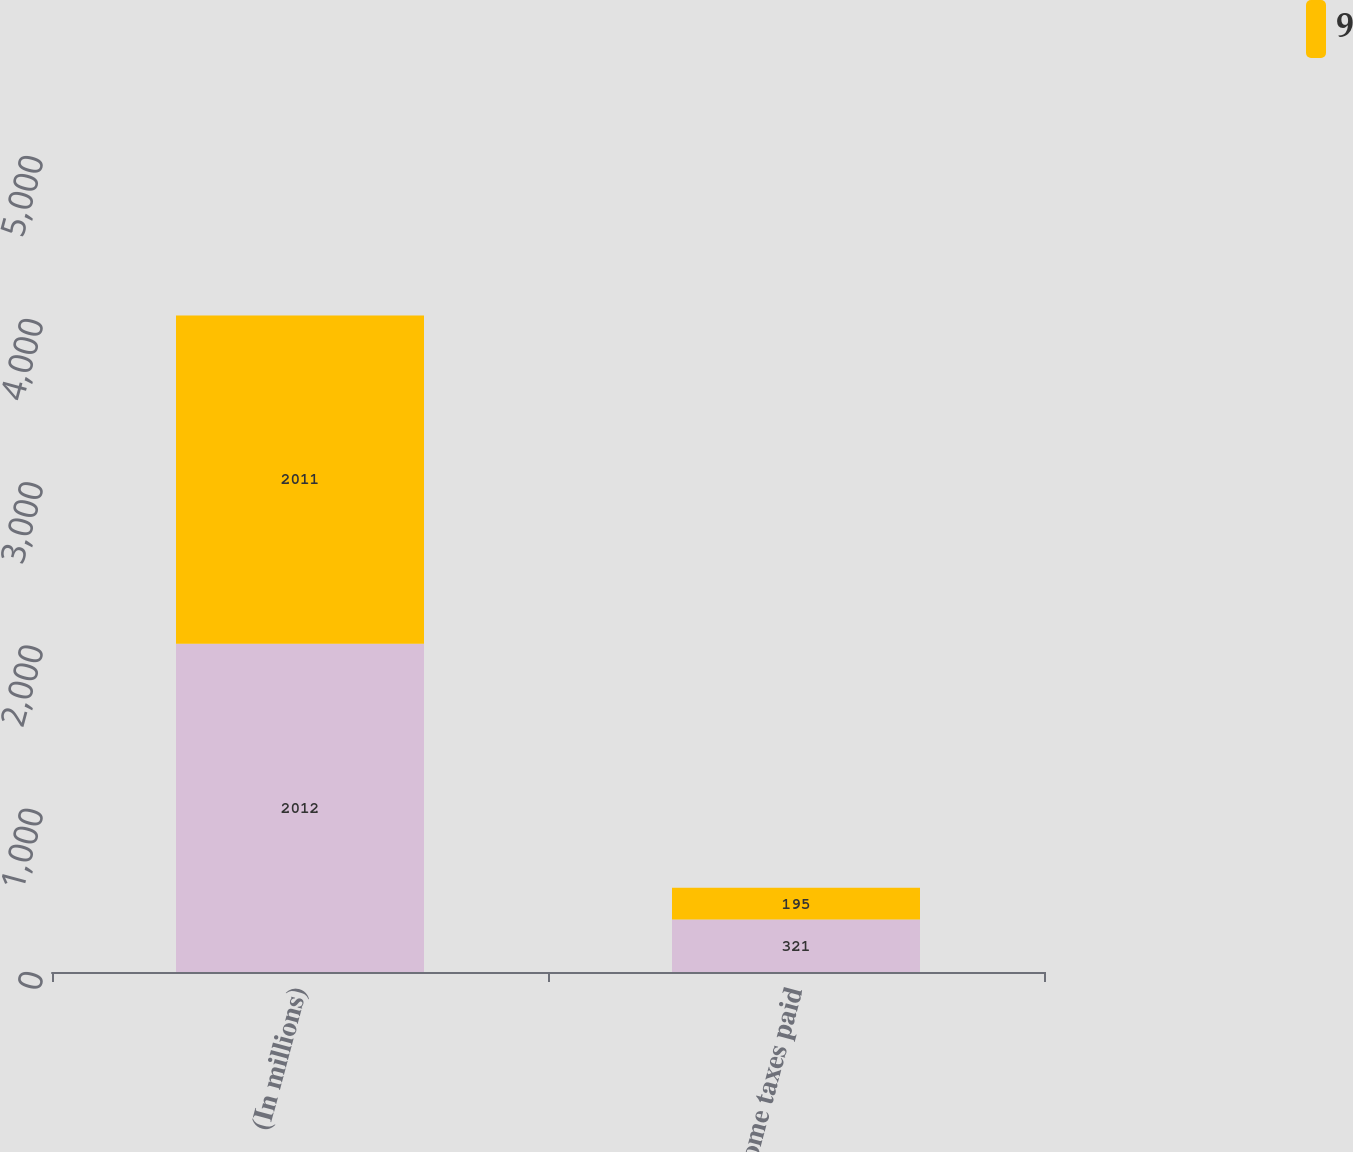Convert chart. <chart><loc_0><loc_0><loc_500><loc_500><stacked_bar_chart><ecel><fcel>(In millions)<fcel>Income taxes paid<nl><fcel>nan<fcel>2012<fcel>321<nl><fcel>9<fcel>2011<fcel>195<nl></chart> 